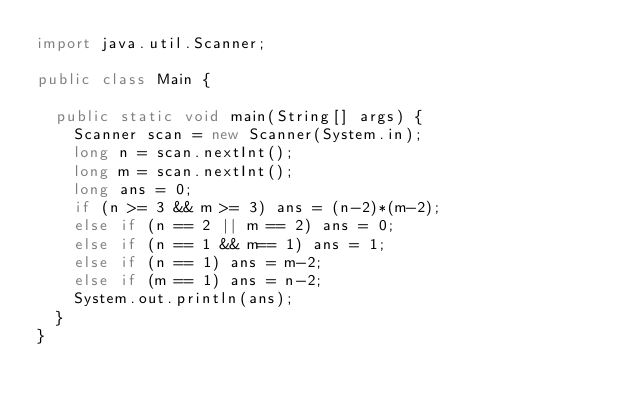<code> <loc_0><loc_0><loc_500><loc_500><_Java_>import java.util.Scanner;

public class Main {

	public static void main(String[] args) {
		Scanner scan = new Scanner(System.in);
		long n = scan.nextInt();
		long m = scan.nextInt();
		long ans = 0;
		if (n >= 3 && m >= 3) ans = (n-2)*(m-2);
		else if (n == 2 || m == 2) ans = 0;
		else if (n == 1 && m== 1) ans = 1;
		else if (n == 1) ans = m-2;
		else if (m == 1) ans = n-2;
		System.out.println(ans);
	}
}
</code> 